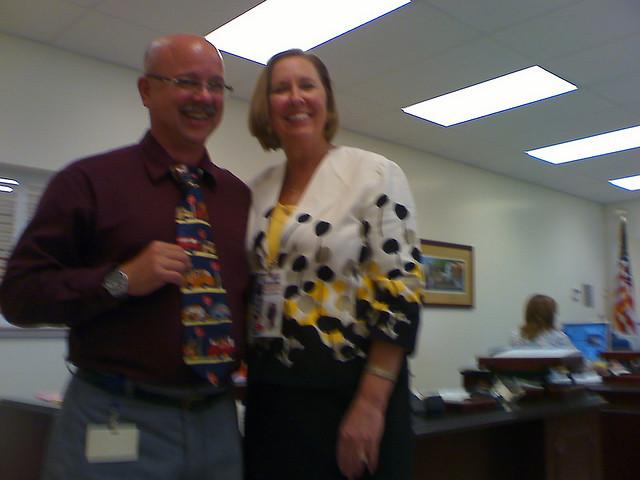Is an adult holding a toy in the picture?
Concise answer only. No. How many people are smiling in this picture?
Answer briefly. 2. Are these office workers?
Quick response, please. Yes. How many people are wearing blue shirts?
Give a very brief answer. 0. Where are these people working?
Quick response, please. Office. Is the woman making healthy choices?
Answer briefly. Yes. How many people are in this picture?
Keep it brief. 3. What is the person wearing a suit is doing?
Write a very short answer. Smiling. What country is the flag?
Quick response, please. Usa. What color is her blouse?
Concise answer only. White. What is on the man's tie?
Be succinct. Cars. Is the man holding umbrella?
Concise answer only. No. What is on the man's face?
Keep it brief. Glasses. What is the man doing?
Keep it brief. Smiling. 